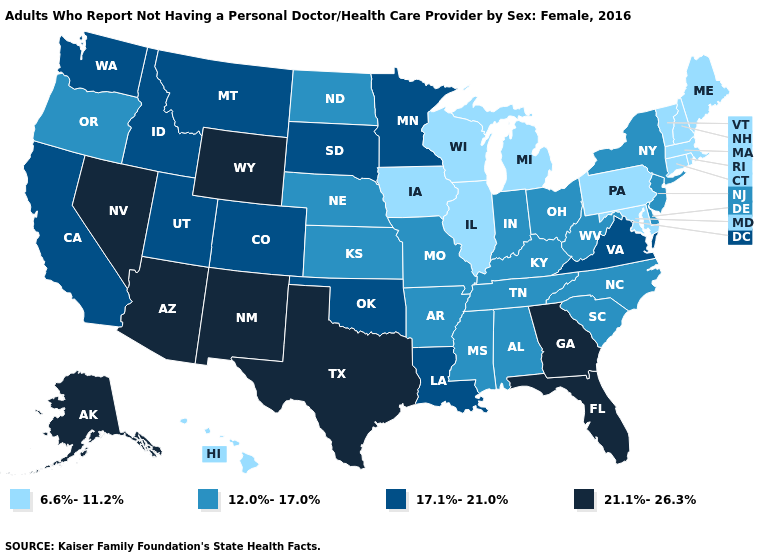What is the value of New York?
Keep it brief. 12.0%-17.0%. Does Rhode Island have the lowest value in the USA?
Quick response, please. Yes. What is the highest value in states that border New Mexico?
Give a very brief answer. 21.1%-26.3%. Which states have the lowest value in the West?
Concise answer only. Hawaii. What is the value of Nebraska?
Answer briefly. 12.0%-17.0%. Name the states that have a value in the range 17.1%-21.0%?
Quick response, please. California, Colorado, Idaho, Louisiana, Minnesota, Montana, Oklahoma, South Dakota, Utah, Virginia, Washington. What is the value of Maine?
Answer briefly. 6.6%-11.2%. What is the highest value in states that border Missouri?
Short answer required. 17.1%-21.0%. Does South Dakota have a lower value than Colorado?
Quick response, please. No. Which states have the lowest value in the South?
Quick response, please. Maryland. Among the states that border New York , which have the highest value?
Be succinct. New Jersey. What is the value of Alaska?
Keep it brief. 21.1%-26.3%. What is the value of Pennsylvania?
Be succinct. 6.6%-11.2%. What is the highest value in the South ?
Short answer required. 21.1%-26.3%. Among the states that border Delaware , which have the highest value?
Be succinct. New Jersey. 